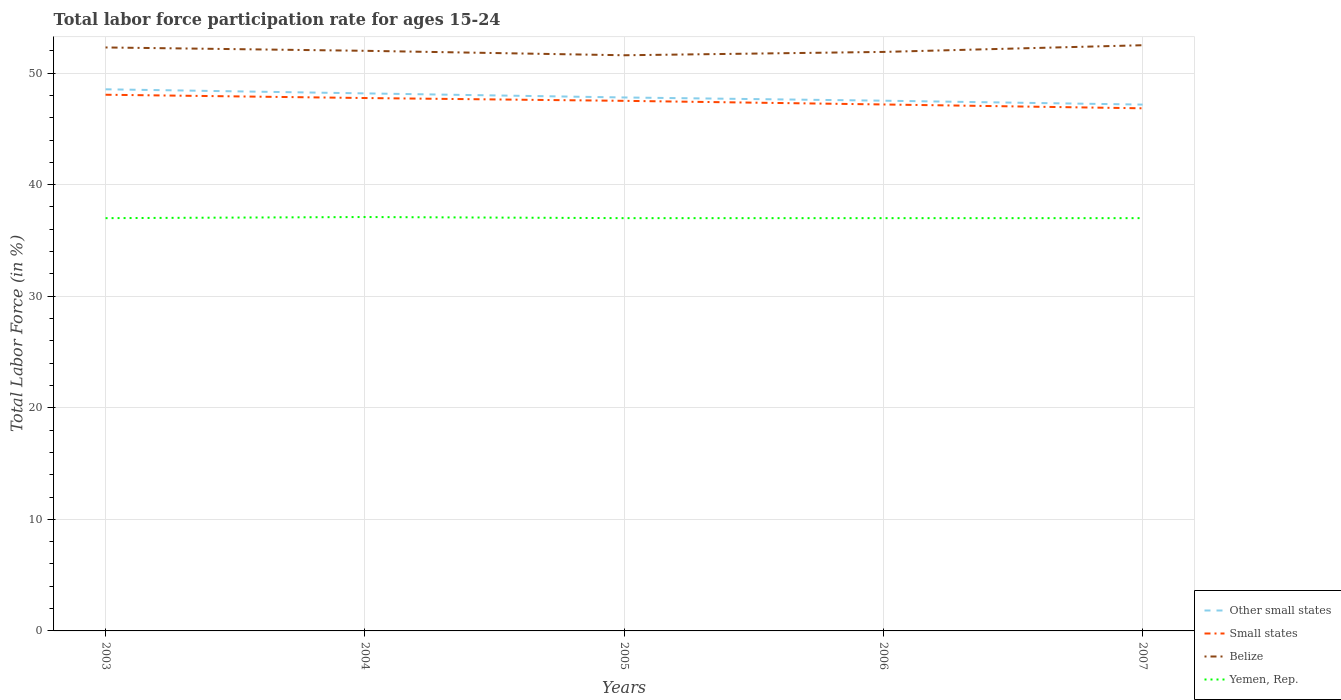How many different coloured lines are there?
Provide a succinct answer. 4. Across all years, what is the maximum labor force participation rate in Belize?
Your response must be concise. 51.6. In which year was the labor force participation rate in Yemen, Rep. maximum?
Your answer should be compact. 2003. What is the total labor force participation rate in Small states in the graph?
Give a very brief answer. 0.55. What is the difference between the highest and the second highest labor force participation rate in Yemen, Rep.?
Keep it short and to the point. 0.1. What is the difference between the highest and the lowest labor force participation rate in Small states?
Keep it short and to the point. 3. Is the labor force participation rate in Other small states strictly greater than the labor force participation rate in Belize over the years?
Give a very brief answer. Yes. Are the values on the major ticks of Y-axis written in scientific E-notation?
Provide a short and direct response. No. Does the graph contain grids?
Keep it short and to the point. Yes. Where does the legend appear in the graph?
Make the answer very short. Bottom right. How many legend labels are there?
Make the answer very short. 4. How are the legend labels stacked?
Your answer should be compact. Vertical. What is the title of the graph?
Provide a short and direct response. Total labor force participation rate for ages 15-24. Does "Panama" appear as one of the legend labels in the graph?
Give a very brief answer. No. What is the label or title of the X-axis?
Your answer should be very brief. Years. What is the Total Labor Force (in %) in Other small states in 2003?
Keep it short and to the point. 48.55. What is the Total Labor Force (in %) in Small states in 2003?
Offer a very short reply. 48.06. What is the Total Labor Force (in %) in Belize in 2003?
Your answer should be compact. 52.3. What is the Total Labor Force (in %) of Other small states in 2004?
Keep it short and to the point. 48.18. What is the Total Labor Force (in %) in Small states in 2004?
Provide a short and direct response. 47.77. What is the Total Labor Force (in %) of Yemen, Rep. in 2004?
Your answer should be very brief. 37.1. What is the Total Labor Force (in %) of Other small states in 2005?
Provide a short and direct response. 47.82. What is the Total Labor Force (in %) in Small states in 2005?
Offer a very short reply. 47.52. What is the Total Labor Force (in %) in Belize in 2005?
Your answer should be very brief. 51.6. What is the Total Labor Force (in %) in Other small states in 2006?
Ensure brevity in your answer.  47.53. What is the Total Labor Force (in %) of Small states in 2006?
Your response must be concise. 47.19. What is the Total Labor Force (in %) in Belize in 2006?
Your response must be concise. 51.9. What is the Total Labor Force (in %) in Other small states in 2007?
Your answer should be very brief. 47.18. What is the Total Labor Force (in %) in Small states in 2007?
Your answer should be very brief. 46.85. What is the Total Labor Force (in %) of Belize in 2007?
Offer a very short reply. 52.5. Across all years, what is the maximum Total Labor Force (in %) of Other small states?
Ensure brevity in your answer.  48.55. Across all years, what is the maximum Total Labor Force (in %) in Small states?
Your answer should be very brief. 48.06. Across all years, what is the maximum Total Labor Force (in %) of Belize?
Your answer should be very brief. 52.5. Across all years, what is the maximum Total Labor Force (in %) of Yemen, Rep.?
Provide a short and direct response. 37.1. Across all years, what is the minimum Total Labor Force (in %) of Other small states?
Offer a very short reply. 47.18. Across all years, what is the minimum Total Labor Force (in %) of Small states?
Provide a succinct answer. 46.85. Across all years, what is the minimum Total Labor Force (in %) in Belize?
Provide a short and direct response. 51.6. Across all years, what is the minimum Total Labor Force (in %) of Yemen, Rep.?
Your response must be concise. 37. What is the total Total Labor Force (in %) of Other small states in the graph?
Your response must be concise. 239.26. What is the total Total Labor Force (in %) in Small states in the graph?
Keep it short and to the point. 237.38. What is the total Total Labor Force (in %) of Belize in the graph?
Provide a short and direct response. 260.3. What is the total Total Labor Force (in %) of Yemen, Rep. in the graph?
Offer a very short reply. 185.1. What is the difference between the Total Labor Force (in %) in Other small states in 2003 and that in 2004?
Keep it short and to the point. 0.37. What is the difference between the Total Labor Force (in %) in Small states in 2003 and that in 2004?
Provide a short and direct response. 0.3. What is the difference between the Total Labor Force (in %) of Belize in 2003 and that in 2004?
Offer a terse response. 0.3. What is the difference between the Total Labor Force (in %) of Yemen, Rep. in 2003 and that in 2004?
Your response must be concise. -0.1. What is the difference between the Total Labor Force (in %) in Other small states in 2003 and that in 2005?
Provide a short and direct response. 0.73. What is the difference between the Total Labor Force (in %) of Small states in 2003 and that in 2005?
Your response must be concise. 0.55. What is the difference between the Total Labor Force (in %) of Other small states in 2003 and that in 2006?
Give a very brief answer. 1.02. What is the difference between the Total Labor Force (in %) in Small states in 2003 and that in 2006?
Your answer should be very brief. 0.87. What is the difference between the Total Labor Force (in %) in Other small states in 2003 and that in 2007?
Provide a succinct answer. 1.37. What is the difference between the Total Labor Force (in %) in Small states in 2003 and that in 2007?
Your response must be concise. 1.22. What is the difference between the Total Labor Force (in %) of Yemen, Rep. in 2003 and that in 2007?
Provide a short and direct response. 0. What is the difference between the Total Labor Force (in %) of Other small states in 2004 and that in 2005?
Your answer should be very brief. 0.37. What is the difference between the Total Labor Force (in %) in Small states in 2004 and that in 2005?
Give a very brief answer. 0.25. What is the difference between the Total Labor Force (in %) in Other small states in 2004 and that in 2006?
Ensure brevity in your answer.  0.66. What is the difference between the Total Labor Force (in %) in Small states in 2004 and that in 2006?
Give a very brief answer. 0.58. What is the difference between the Total Labor Force (in %) of Belize in 2004 and that in 2006?
Your response must be concise. 0.1. What is the difference between the Total Labor Force (in %) of Small states in 2004 and that in 2007?
Keep it short and to the point. 0.92. What is the difference between the Total Labor Force (in %) of Other small states in 2005 and that in 2006?
Offer a terse response. 0.29. What is the difference between the Total Labor Force (in %) in Small states in 2005 and that in 2006?
Provide a short and direct response. 0.33. What is the difference between the Total Labor Force (in %) in Yemen, Rep. in 2005 and that in 2006?
Keep it short and to the point. 0. What is the difference between the Total Labor Force (in %) of Other small states in 2005 and that in 2007?
Offer a very short reply. 0.64. What is the difference between the Total Labor Force (in %) in Small states in 2005 and that in 2007?
Make the answer very short. 0.67. What is the difference between the Total Labor Force (in %) of Belize in 2005 and that in 2007?
Make the answer very short. -0.9. What is the difference between the Total Labor Force (in %) of Other small states in 2006 and that in 2007?
Keep it short and to the point. 0.35. What is the difference between the Total Labor Force (in %) in Small states in 2006 and that in 2007?
Give a very brief answer. 0.34. What is the difference between the Total Labor Force (in %) in Other small states in 2003 and the Total Labor Force (in %) in Small states in 2004?
Ensure brevity in your answer.  0.78. What is the difference between the Total Labor Force (in %) of Other small states in 2003 and the Total Labor Force (in %) of Belize in 2004?
Your response must be concise. -3.45. What is the difference between the Total Labor Force (in %) of Other small states in 2003 and the Total Labor Force (in %) of Yemen, Rep. in 2004?
Offer a very short reply. 11.45. What is the difference between the Total Labor Force (in %) of Small states in 2003 and the Total Labor Force (in %) of Belize in 2004?
Keep it short and to the point. -3.94. What is the difference between the Total Labor Force (in %) of Small states in 2003 and the Total Labor Force (in %) of Yemen, Rep. in 2004?
Offer a terse response. 10.96. What is the difference between the Total Labor Force (in %) of Other small states in 2003 and the Total Labor Force (in %) of Small states in 2005?
Provide a short and direct response. 1.03. What is the difference between the Total Labor Force (in %) in Other small states in 2003 and the Total Labor Force (in %) in Belize in 2005?
Provide a succinct answer. -3.05. What is the difference between the Total Labor Force (in %) of Other small states in 2003 and the Total Labor Force (in %) of Yemen, Rep. in 2005?
Give a very brief answer. 11.55. What is the difference between the Total Labor Force (in %) of Small states in 2003 and the Total Labor Force (in %) of Belize in 2005?
Offer a very short reply. -3.54. What is the difference between the Total Labor Force (in %) in Small states in 2003 and the Total Labor Force (in %) in Yemen, Rep. in 2005?
Offer a very short reply. 11.06. What is the difference between the Total Labor Force (in %) of Belize in 2003 and the Total Labor Force (in %) of Yemen, Rep. in 2005?
Your response must be concise. 15.3. What is the difference between the Total Labor Force (in %) of Other small states in 2003 and the Total Labor Force (in %) of Small states in 2006?
Give a very brief answer. 1.36. What is the difference between the Total Labor Force (in %) in Other small states in 2003 and the Total Labor Force (in %) in Belize in 2006?
Your answer should be compact. -3.35. What is the difference between the Total Labor Force (in %) in Other small states in 2003 and the Total Labor Force (in %) in Yemen, Rep. in 2006?
Keep it short and to the point. 11.55. What is the difference between the Total Labor Force (in %) in Small states in 2003 and the Total Labor Force (in %) in Belize in 2006?
Offer a terse response. -3.84. What is the difference between the Total Labor Force (in %) in Small states in 2003 and the Total Labor Force (in %) in Yemen, Rep. in 2006?
Keep it short and to the point. 11.06. What is the difference between the Total Labor Force (in %) of Other small states in 2003 and the Total Labor Force (in %) of Small states in 2007?
Your answer should be compact. 1.7. What is the difference between the Total Labor Force (in %) in Other small states in 2003 and the Total Labor Force (in %) in Belize in 2007?
Your response must be concise. -3.95. What is the difference between the Total Labor Force (in %) of Other small states in 2003 and the Total Labor Force (in %) of Yemen, Rep. in 2007?
Offer a very short reply. 11.55. What is the difference between the Total Labor Force (in %) in Small states in 2003 and the Total Labor Force (in %) in Belize in 2007?
Ensure brevity in your answer.  -4.44. What is the difference between the Total Labor Force (in %) of Small states in 2003 and the Total Labor Force (in %) of Yemen, Rep. in 2007?
Your answer should be compact. 11.06. What is the difference between the Total Labor Force (in %) in Belize in 2003 and the Total Labor Force (in %) in Yemen, Rep. in 2007?
Give a very brief answer. 15.3. What is the difference between the Total Labor Force (in %) in Other small states in 2004 and the Total Labor Force (in %) in Small states in 2005?
Give a very brief answer. 0.67. What is the difference between the Total Labor Force (in %) in Other small states in 2004 and the Total Labor Force (in %) in Belize in 2005?
Offer a terse response. -3.42. What is the difference between the Total Labor Force (in %) of Other small states in 2004 and the Total Labor Force (in %) of Yemen, Rep. in 2005?
Offer a very short reply. 11.18. What is the difference between the Total Labor Force (in %) in Small states in 2004 and the Total Labor Force (in %) in Belize in 2005?
Keep it short and to the point. -3.83. What is the difference between the Total Labor Force (in %) of Small states in 2004 and the Total Labor Force (in %) of Yemen, Rep. in 2005?
Offer a terse response. 10.77. What is the difference between the Total Labor Force (in %) of Belize in 2004 and the Total Labor Force (in %) of Yemen, Rep. in 2005?
Keep it short and to the point. 15. What is the difference between the Total Labor Force (in %) in Other small states in 2004 and the Total Labor Force (in %) in Small states in 2006?
Your answer should be compact. 0.99. What is the difference between the Total Labor Force (in %) in Other small states in 2004 and the Total Labor Force (in %) in Belize in 2006?
Your answer should be compact. -3.72. What is the difference between the Total Labor Force (in %) in Other small states in 2004 and the Total Labor Force (in %) in Yemen, Rep. in 2006?
Your answer should be very brief. 11.18. What is the difference between the Total Labor Force (in %) in Small states in 2004 and the Total Labor Force (in %) in Belize in 2006?
Make the answer very short. -4.13. What is the difference between the Total Labor Force (in %) of Small states in 2004 and the Total Labor Force (in %) of Yemen, Rep. in 2006?
Offer a very short reply. 10.77. What is the difference between the Total Labor Force (in %) of Other small states in 2004 and the Total Labor Force (in %) of Small states in 2007?
Your answer should be compact. 1.34. What is the difference between the Total Labor Force (in %) of Other small states in 2004 and the Total Labor Force (in %) of Belize in 2007?
Provide a short and direct response. -4.32. What is the difference between the Total Labor Force (in %) of Other small states in 2004 and the Total Labor Force (in %) of Yemen, Rep. in 2007?
Make the answer very short. 11.18. What is the difference between the Total Labor Force (in %) in Small states in 2004 and the Total Labor Force (in %) in Belize in 2007?
Provide a succinct answer. -4.73. What is the difference between the Total Labor Force (in %) in Small states in 2004 and the Total Labor Force (in %) in Yemen, Rep. in 2007?
Provide a succinct answer. 10.77. What is the difference between the Total Labor Force (in %) of Belize in 2004 and the Total Labor Force (in %) of Yemen, Rep. in 2007?
Your response must be concise. 15. What is the difference between the Total Labor Force (in %) of Other small states in 2005 and the Total Labor Force (in %) of Small states in 2006?
Provide a short and direct response. 0.63. What is the difference between the Total Labor Force (in %) of Other small states in 2005 and the Total Labor Force (in %) of Belize in 2006?
Provide a short and direct response. -4.08. What is the difference between the Total Labor Force (in %) in Other small states in 2005 and the Total Labor Force (in %) in Yemen, Rep. in 2006?
Offer a terse response. 10.82. What is the difference between the Total Labor Force (in %) of Small states in 2005 and the Total Labor Force (in %) of Belize in 2006?
Your response must be concise. -4.38. What is the difference between the Total Labor Force (in %) in Small states in 2005 and the Total Labor Force (in %) in Yemen, Rep. in 2006?
Provide a succinct answer. 10.52. What is the difference between the Total Labor Force (in %) in Belize in 2005 and the Total Labor Force (in %) in Yemen, Rep. in 2006?
Give a very brief answer. 14.6. What is the difference between the Total Labor Force (in %) of Other small states in 2005 and the Total Labor Force (in %) of Small states in 2007?
Provide a succinct answer. 0.97. What is the difference between the Total Labor Force (in %) in Other small states in 2005 and the Total Labor Force (in %) in Belize in 2007?
Your answer should be compact. -4.68. What is the difference between the Total Labor Force (in %) of Other small states in 2005 and the Total Labor Force (in %) of Yemen, Rep. in 2007?
Provide a short and direct response. 10.82. What is the difference between the Total Labor Force (in %) in Small states in 2005 and the Total Labor Force (in %) in Belize in 2007?
Provide a succinct answer. -4.98. What is the difference between the Total Labor Force (in %) of Small states in 2005 and the Total Labor Force (in %) of Yemen, Rep. in 2007?
Your answer should be very brief. 10.52. What is the difference between the Total Labor Force (in %) of Belize in 2005 and the Total Labor Force (in %) of Yemen, Rep. in 2007?
Provide a short and direct response. 14.6. What is the difference between the Total Labor Force (in %) of Other small states in 2006 and the Total Labor Force (in %) of Small states in 2007?
Your answer should be very brief. 0.68. What is the difference between the Total Labor Force (in %) of Other small states in 2006 and the Total Labor Force (in %) of Belize in 2007?
Ensure brevity in your answer.  -4.97. What is the difference between the Total Labor Force (in %) of Other small states in 2006 and the Total Labor Force (in %) of Yemen, Rep. in 2007?
Offer a terse response. 10.53. What is the difference between the Total Labor Force (in %) of Small states in 2006 and the Total Labor Force (in %) of Belize in 2007?
Ensure brevity in your answer.  -5.31. What is the difference between the Total Labor Force (in %) of Small states in 2006 and the Total Labor Force (in %) of Yemen, Rep. in 2007?
Your answer should be very brief. 10.19. What is the average Total Labor Force (in %) in Other small states per year?
Your answer should be very brief. 47.85. What is the average Total Labor Force (in %) of Small states per year?
Your response must be concise. 47.48. What is the average Total Labor Force (in %) in Belize per year?
Provide a succinct answer. 52.06. What is the average Total Labor Force (in %) in Yemen, Rep. per year?
Your response must be concise. 37.02. In the year 2003, what is the difference between the Total Labor Force (in %) of Other small states and Total Labor Force (in %) of Small states?
Offer a terse response. 0.49. In the year 2003, what is the difference between the Total Labor Force (in %) in Other small states and Total Labor Force (in %) in Belize?
Provide a short and direct response. -3.75. In the year 2003, what is the difference between the Total Labor Force (in %) of Other small states and Total Labor Force (in %) of Yemen, Rep.?
Your answer should be very brief. 11.55. In the year 2003, what is the difference between the Total Labor Force (in %) in Small states and Total Labor Force (in %) in Belize?
Offer a very short reply. -4.24. In the year 2003, what is the difference between the Total Labor Force (in %) in Small states and Total Labor Force (in %) in Yemen, Rep.?
Make the answer very short. 11.06. In the year 2003, what is the difference between the Total Labor Force (in %) of Belize and Total Labor Force (in %) of Yemen, Rep.?
Your response must be concise. 15.3. In the year 2004, what is the difference between the Total Labor Force (in %) of Other small states and Total Labor Force (in %) of Small states?
Offer a very short reply. 0.42. In the year 2004, what is the difference between the Total Labor Force (in %) in Other small states and Total Labor Force (in %) in Belize?
Your answer should be compact. -3.82. In the year 2004, what is the difference between the Total Labor Force (in %) in Other small states and Total Labor Force (in %) in Yemen, Rep.?
Offer a terse response. 11.08. In the year 2004, what is the difference between the Total Labor Force (in %) in Small states and Total Labor Force (in %) in Belize?
Ensure brevity in your answer.  -4.23. In the year 2004, what is the difference between the Total Labor Force (in %) of Small states and Total Labor Force (in %) of Yemen, Rep.?
Your answer should be very brief. 10.67. In the year 2005, what is the difference between the Total Labor Force (in %) in Other small states and Total Labor Force (in %) in Small states?
Provide a short and direct response. 0.3. In the year 2005, what is the difference between the Total Labor Force (in %) of Other small states and Total Labor Force (in %) of Belize?
Make the answer very short. -3.78. In the year 2005, what is the difference between the Total Labor Force (in %) in Other small states and Total Labor Force (in %) in Yemen, Rep.?
Keep it short and to the point. 10.82. In the year 2005, what is the difference between the Total Labor Force (in %) in Small states and Total Labor Force (in %) in Belize?
Provide a short and direct response. -4.08. In the year 2005, what is the difference between the Total Labor Force (in %) in Small states and Total Labor Force (in %) in Yemen, Rep.?
Offer a very short reply. 10.52. In the year 2006, what is the difference between the Total Labor Force (in %) of Other small states and Total Labor Force (in %) of Small states?
Provide a short and direct response. 0.34. In the year 2006, what is the difference between the Total Labor Force (in %) of Other small states and Total Labor Force (in %) of Belize?
Provide a short and direct response. -4.37. In the year 2006, what is the difference between the Total Labor Force (in %) in Other small states and Total Labor Force (in %) in Yemen, Rep.?
Keep it short and to the point. 10.53. In the year 2006, what is the difference between the Total Labor Force (in %) in Small states and Total Labor Force (in %) in Belize?
Make the answer very short. -4.71. In the year 2006, what is the difference between the Total Labor Force (in %) in Small states and Total Labor Force (in %) in Yemen, Rep.?
Keep it short and to the point. 10.19. In the year 2007, what is the difference between the Total Labor Force (in %) in Other small states and Total Labor Force (in %) in Small states?
Offer a very short reply. 0.33. In the year 2007, what is the difference between the Total Labor Force (in %) of Other small states and Total Labor Force (in %) of Belize?
Provide a short and direct response. -5.32. In the year 2007, what is the difference between the Total Labor Force (in %) of Other small states and Total Labor Force (in %) of Yemen, Rep.?
Provide a short and direct response. 10.18. In the year 2007, what is the difference between the Total Labor Force (in %) in Small states and Total Labor Force (in %) in Belize?
Give a very brief answer. -5.65. In the year 2007, what is the difference between the Total Labor Force (in %) of Small states and Total Labor Force (in %) of Yemen, Rep.?
Your answer should be compact. 9.85. In the year 2007, what is the difference between the Total Labor Force (in %) in Belize and Total Labor Force (in %) in Yemen, Rep.?
Your answer should be compact. 15.5. What is the ratio of the Total Labor Force (in %) of Other small states in 2003 to that in 2004?
Make the answer very short. 1.01. What is the ratio of the Total Labor Force (in %) in Small states in 2003 to that in 2004?
Offer a very short reply. 1.01. What is the ratio of the Total Labor Force (in %) in Belize in 2003 to that in 2004?
Offer a terse response. 1.01. What is the ratio of the Total Labor Force (in %) of Yemen, Rep. in 2003 to that in 2004?
Offer a very short reply. 1. What is the ratio of the Total Labor Force (in %) in Other small states in 2003 to that in 2005?
Your response must be concise. 1.02. What is the ratio of the Total Labor Force (in %) of Small states in 2003 to that in 2005?
Keep it short and to the point. 1.01. What is the ratio of the Total Labor Force (in %) of Belize in 2003 to that in 2005?
Provide a succinct answer. 1.01. What is the ratio of the Total Labor Force (in %) in Yemen, Rep. in 2003 to that in 2005?
Offer a terse response. 1. What is the ratio of the Total Labor Force (in %) in Other small states in 2003 to that in 2006?
Keep it short and to the point. 1.02. What is the ratio of the Total Labor Force (in %) of Small states in 2003 to that in 2006?
Keep it short and to the point. 1.02. What is the ratio of the Total Labor Force (in %) in Belize in 2003 to that in 2006?
Offer a terse response. 1.01. What is the ratio of the Total Labor Force (in %) in Other small states in 2003 to that in 2007?
Your answer should be compact. 1.03. What is the ratio of the Total Labor Force (in %) in Small states in 2003 to that in 2007?
Offer a terse response. 1.03. What is the ratio of the Total Labor Force (in %) of Other small states in 2004 to that in 2005?
Ensure brevity in your answer.  1.01. What is the ratio of the Total Labor Force (in %) of Belize in 2004 to that in 2005?
Ensure brevity in your answer.  1.01. What is the ratio of the Total Labor Force (in %) of Other small states in 2004 to that in 2006?
Make the answer very short. 1.01. What is the ratio of the Total Labor Force (in %) of Small states in 2004 to that in 2006?
Your answer should be very brief. 1.01. What is the ratio of the Total Labor Force (in %) of Yemen, Rep. in 2004 to that in 2006?
Offer a terse response. 1. What is the ratio of the Total Labor Force (in %) of Other small states in 2004 to that in 2007?
Ensure brevity in your answer.  1.02. What is the ratio of the Total Labor Force (in %) of Small states in 2004 to that in 2007?
Provide a succinct answer. 1.02. What is the ratio of the Total Labor Force (in %) in Belize in 2004 to that in 2007?
Your answer should be compact. 0.99. What is the ratio of the Total Labor Force (in %) of Yemen, Rep. in 2005 to that in 2006?
Keep it short and to the point. 1. What is the ratio of the Total Labor Force (in %) in Other small states in 2005 to that in 2007?
Your answer should be very brief. 1.01. What is the ratio of the Total Labor Force (in %) of Small states in 2005 to that in 2007?
Ensure brevity in your answer.  1.01. What is the ratio of the Total Labor Force (in %) in Belize in 2005 to that in 2007?
Provide a succinct answer. 0.98. What is the ratio of the Total Labor Force (in %) of Yemen, Rep. in 2005 to that in 2007?
Ensure brevity in your answer.  1. What is the ratio of the Total Labor Force (in %) in Other small states in 2006 to that in 2007?
Provide a succinct answer. 1.01. What is the ratio of the Total Labor Force (in %) of Small states in 2006 to that in 2007?
Your answer should be compact. 1.01. What is the difference between the highest and the second highest Total Labor Force (in %) of Other small states?
Your response must be concise. 0.37. What is the difference between the highest and the second highest Total Labor Force (in %) in Small states?
Ensure brevity in your answer.  0.3. What is the difference between the highest and the second highest Total Labor Force (in %) in Belize?
Make the answer very short. 0.2. What is the difference between the highest and the second highest Total Labor Force (in %) of Yemen, Rep.?
Offer a terse response. 0.1. What is the difference between the highest and the lowest Total Labor Force (in %) of Other small states?
Your response must be concise. 1.37. What is the difference between the highest and the lowest Total Labor Force (in %) in Small states?
Give a very brief answer. 1.22. What is the difference between the highest and the lowest Total Labor Force (in %) in Belize?
Your answer should be compact. 0.9. What is the difference between the highest and the lowest Total Labor Force (in %) in Yemen, Rep.?
Provide a short and direct response. 0.1. 